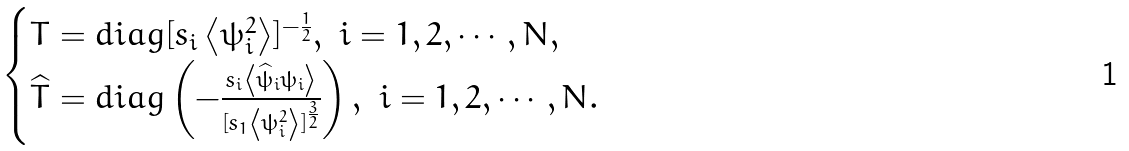<formula> <loc_0><loc_0><loc_500><loc_500>\begin{cases} T = d i a g [ s _ { i } \left < \psi _ { i } ^ { 2 } \right > ] ^ { - \frac { 1 } { 2 } } , \ i = 1 , 2 , \cdots , N , \\ \widehat { T } = d i a g \left ( - \frac { s _ { i } \left < \widehat { \psi } _ { i } \psi _ { i } \right > } { [ s _ { 1 } \left < \psi ^ { 2 } _ { i } \right > ] ^ { \frac { 3 } { 2 } } } \right ) , \ i = 1 , 2 , \cdots , N . \end{cases}</formula> 